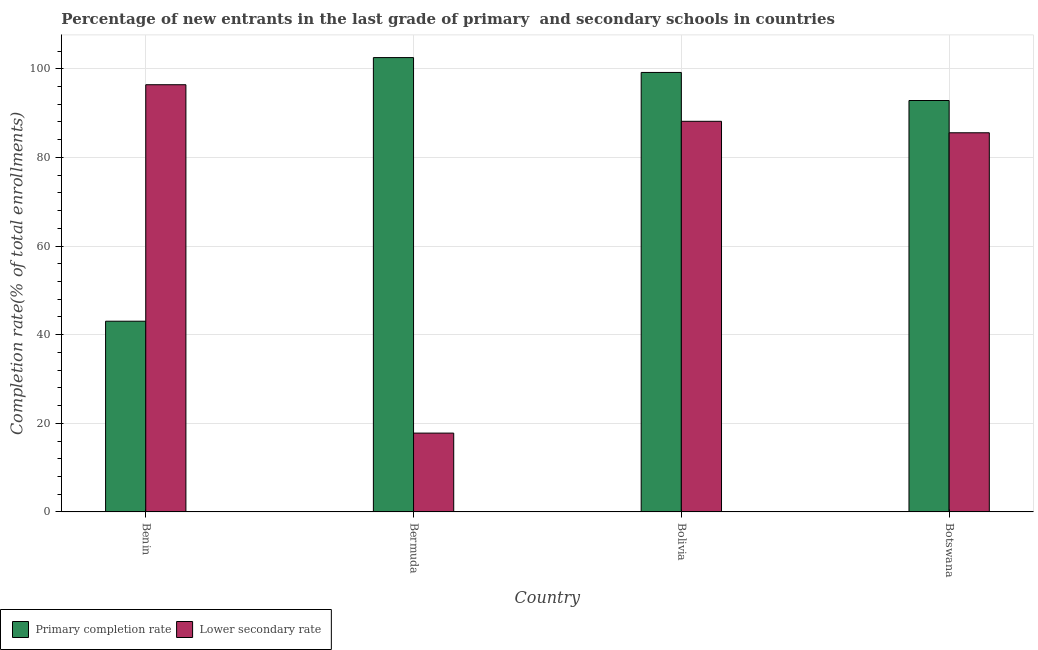How many different coloured bars are there?
Your answer should be very brief. 2. Are the number of bars on each tick of the X-axis equal?
Your answer should be very brief. Yes. How many bars are there on the 3rd tick from the left?
Your answer should be very brief. 2. How many bars are there on the 2nd tick from the right?
Make the answer very short. 2. What is the label of the 2nd group of bars from the left?
Your response must be concise. Bermuda. What is the completion rate in secondary schools in Bolivia?
Provide a succinct answer. 88.15. Across all countries, what is the maximum completion rate in secondary schools?
Ensure brevity in your answer.  96.4. Across all countries, what is the minimum completion rate in secondary schools?
Provide a short and direct response. 17.78. In which country was the completion rate in secondary schools maximum?
Provide a succinct answer. Benin. In which country was the completion rate in primary schools minimum?
Provide a succinct answer. Benin. What is the total completion rate in primary schools in the graph?
Your answer should be compact. 337.57. What is the difference between the completion rate in primary schools in Benin and that in Botswana?
Give a very brief answer. -49.8. What is the difference between the completion rate in primary schools in Bolivia and the completion rate in secondary schools in Bermuda?
Your answer should be very brief. 81.39. What is the average completion rate in primary schools per country?
Your answer should be compact. 84.39. What is the difference between the completion rate in secondary schools and completion rate in primary schools in Bolivia?
Provide a short and direct response. -11.02. What is the ratio of the completion rate in secondary schools in Benin to that in Bermuda?
Your answer should be compact. 5.42. Is the completion rate in secondary schools in Bolivia less than that in Botswana?
Provide a succinct answer. No. Is the difference between the completion rate in secondary schools in Bolivia and Botswana greater than the difference between the completion rate in primary schools in Bolivia and Botswana?
Offer a very short reply. No. What is the difference between the highest and the second highest completion rate in primary schools?
Provide a succinct answer. 3.35. What is the difference between the highest and the lowest completion rate in secondary schools?
Your answer should be compact. 78.62. In how many countries, is the completion rate in secondary schools greater than the average completion rate in secondary schools taken over all countries?
Give a very brief answer. 3. What does the 2nd bar from the left in Botswana represents?
Your answer should be very brief. Lower secondary rate. What does the 2nd bar from the right in Benin represents?
Offer a terse response. Primary completion rate. How many bars are there?
Your answer should be compact. 8. Are the values on the major ticks of Y-axis written in scientific E-notation?
Give a very brief answer. No. How many legend labels are there?
Ensure brevity in your answer.  2. How are the legend labels stacked?
Provide a succinct answer. Horizontal. What is the title of the graph?
Give a very brief answer. Percentage of new entrants in the last grade of primary  and secondary schools in countries. What is the label or title of the Y-axis?
Ensure brevity in your answer.  Completion rate(% of total enrollments). What is the Completion rate(% of total enrollments) in Primary completion rate in Benin?
Provide a short and direct response. 43.03. What is the Completion rate(% of total enrollments) of Lower secondary rate in Benin?
Provide a succinct answer. 96.4. What is the Completion rate(% of total enrollments) of Primary completion rate in Bermuda?
Your answer should be compact. 102.52. What is the Completion rate(% of total enrollments) in Lower secondary rate in Bermuda?
Provide a succinct answer. 17.78. What is the Completion rate(% of total enrollments) in Primary completion rate in Bolivia?
Your answer should be very brief. 99.17. What is the Completion rate(% of total enrollments) of Lower secondary rate in Bolivia?
Keep it short and to the point. 88.15. What is the Completion rate(% of total enrollments) of Primary completion rate in Botswana?
Make the answer very short. 92.84. What is the Completion rate(% of total enrollments) of Lower secondary rate in Botswana?
Keep it short and to the point. 85.56. Across all countries, what is the maximum Completion rate(% of total enrollments) of Primary completion rate?
Make the answer very short. 102.52. Across all countries, what is the maximum Completion rate(% of total enrollments) in Lower secondary rate?
Ensure brevity in your answer.  96.4. Across all countries, what is the minimum Completion rate(% of total enrollments) of Primary completion rate?
Offer a terse response. 43.03. Across all countries, what is the minimum Completion rate(% of total enrollments) in Lower secondary rate?
Your answer should be compact. 17.78. What is the total Completion rate(% of total enrollments) in Primary completion rate in the graph?
Offer a very short reply. 337.57. What is the total Completion rate(% of total enrollments) in Lower secondary rate in the graph?
Give a very brief answer. 287.89. What is the difference between the Completion rate(% of total enrollments) of Primary completion rate in Benin and that in Bermuda?
Your answer should be very brief. -59.49. What is the difference between the Completion rate(% of total enrollments) of Lower secondary rate in Benin and that in Bermuda?
Keep it short and to the point. 78.62. What is the difference between the Completion rate(% of total enrollments) of Primary completion rate in Benin and that in Bolivia?
Offer a terse response. -56.14. What is the difference between the Completion rate(% of total enrollments) of Lower secondary rate in Benin and that in Bolivia?
Your answer should be compact. 8.25. What is the difference between the Completion rate(% of total enrollments) of Primary completion rate in Benin and that in Botswana?
Your answer should be compact. -49.8. What is the difference between the Completion rate(% of total enrollments) in Lower secondary rate in Benin and that in Botswana?
Give a very brief answer. 10.85. What is the difference between the Completion rate(% of total enrollments) in Primary completion rate in Bermuda and that in Bolivia?
Your answer should be very brief. 3.35. What is the difference between the Completion rate(% of total enrollments) in Lower secondary rate in Bermuda and that in Bolivia?
Offer a very short reply. -70.36. What is the difference between the Completion rate(% of total enrollments) of Primary completion rate in Bermuda and that in Botswana?
Offer a very short reply. 9.69. What is the difference between the Completion rate(% of total enrollments) of Lower secondary rate in Bermuda and that in Botswana?
Offer a terse response. -67.77. What is the difference between the Completion rate(% of total enrollments) of Primary completion rate in Bolivia and that in Botswana?
Your answer should be compact. 6.33. What is the difference between the Completion rate(% of total enrollments) of Lower secondary rate in Bolivia and that in Botswana?
Offer a very short reply. 2.59. What is the difference between the Completion rate(% of total enrollments) of Primary completion rate in Benin and the Completion rate(% of total enrollments) of Lower secondary rate in Bermuda?
Give a very brief answer. 25.25. What is the difference between the Completion rate(% of total enrollments) of Primary completion rate in Benin and the Completion rate(% of total enrollments) of Lower secondary rate in Bolivia?
Provide a short and direct response. -45.11. What is the difference between the Completion rate(% of total enrollments) in Primary completion rate in Benin and the Completion rate(% of total enrollments) in Lower secondary rate in Botswana?
Give a very brief answer. -42.52. What is the difference between the Completion rate(% of total enrollments) of Primary completion rate in Bermuda and the Completion rate(% of total enrollments) of Lower secondary rate in Bolivia?
Provide a short and direct response. 14.38. What is the difference between the Completion rate(% of total enrollments) of Primary completion rate in Bermuda and the Completion rate(% of total enrollments) of Lower secondary rate in Botswana?
Give a very brief answer. 16.97. What is the difference between the Completion rate(% of total enrollments) of Primary completion rate in Bolivia and the Completion rate(% of total enrollments) of Lower secondary rate in Botswana?
Keep it short and to the point. 13.61. What is the average Completion rate(% of total enrollments) of Primary completion rate per country?
Your response must be concise. 84.39. What is the average Completion rate(% of total enrollments) in Lower secondary rate per country?
Give a very brief answer. 71.97. What is the difference between the Completion rate(% of total enrollments) of Primary completion rate and Completion rate(% of total enrollments) of Lower secondary rate in Benin?
Provide a short and direct response. -53.37. What is the difference between the Completion rate(% of total enrollments) in Primary completion rate and Completion rate(% of total enrollments) in Lower secondary rate in Bermuda?
Your answer should be compact. 84.74. What is the difference between the Completion rate(% of total enrollments) of Primary completion rate and Completion rate(% of total enrollments) of Lower secondary rate in Bolivia?
Your response must be concise. 11.02. What is the difference between the Completion rate(% of total enrollments) in Primary completion rate and Completion rate(% of total enrollments) in Lower secondary rate in Botswana?
Keep it short and to the point. 7.28. What is the ratio of the Completion rate(% of total enrollments) in Primary completion rate in Benin to that in Bermuda?
Ensure brevity in your answer.  0.42. What is the ratio of the Completion rate(% of total enrollments) of Lower secondary rate in Benin to that in Bermuda?
Your response must be concise. 5.42. What is the ratio of the Completion rate(% of total enrollments) of Primary completion rate in Benin to that in Bolivia?
Ensure brevity in your answer.  0.43. What is the ratio of the Completion rate(% of total enrollments) in Lower secondary rate in Benin to that in Bolivia?
Your response must be concise. 1.09. What is the ratio of the Completion rate(% of total enrollments) of Primary completion rate in Benin to that in Botswana?
Your answer should be very brief. 0.46. What is the ratio of the Completion rate(% of total enrollments) of Lower secondary rate in Benin to that in Botswana?
Give a very brief answer. 1.13. What is the ratio of the Completion rate(% of total enrollments) of Primary completion rate in Bermuda to that in Bolivia?
Give a very brief answer. 1.03. What is the ratio of the Completion rate(% of total enrollments) in Lower secondary rate in Bermuda to that in Bolivia?
Your response must be concise. 0.2. What is the ratio of the Completion rate(% of total enrollments) in Primary completion rate in Bermuda to that in Botswana?
Offer a very short reply. 1.1. What is the ratio of the Completion rate(% of total enrollments) in Lower secondary rate in Bermuda to that in Botswana?
Provide a short and direct response. 0.21. What is the ratio of the Completion rate(% of total enrollments) of Primary completion rate in Bolivia to that in Botswana?
Your response must be concise. 1.07. What is the ratio of the Completion rate(% of total enrollments) of Lower secondary rate in Bolivia to that in Botswana?
Offer a terse response. 1.03. What is the difference between the highest and the second highest Completion rate(% of total enrollments) of Primary completion rate?
Give a very brief answer. 3.35. What is the difference between the highest and the second highest Completion rate(% of total enrollments) of Lower secondary rate?
Your answer should be very brief. 8.25. What is the difference between the highest and the lowest Completion rate(% of total enrollments) in Primary completion rate?
Ensure brevity in your answer.  59.49. What is the difference between the highest and the lowest Completion rate(% of total enrollments) in Lower secondary rate?
Provide a short and direct response. 78.62. 